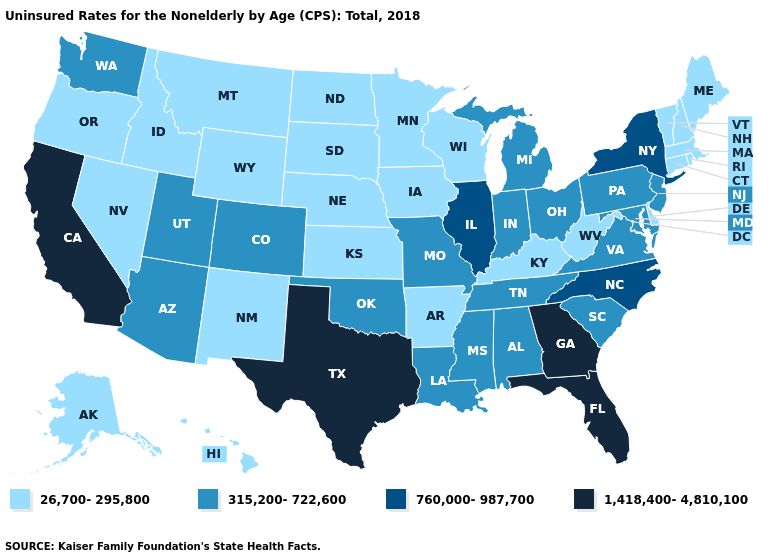What is the highest value in the MidWest ?
Write a very short answer. 760,000-987,700. How many symbols are there in the legend?
Write a very short answer. 4. What is the value of Massachusetts?
Quick response, please. 26,700-295,800. Does California have a higher value than Florida?
Concise answer only. No. What is the value of Ohio?
Quick response, please. 315,200-722,600. Among the states that border Texas , does Louisiana have the highest value?
Short answer required. Yes. What is the lowest value in the West?
Be succinct. 26,700-295,800. What is the highest value in the USA?
Answer briefly. 1,418,400-4,810,100. Which states have the lowest value in the USA?
Write a very short answer. Alaska, Arkansas, Connecticut, Delaware, Hawaii, Idaho, Iowa, Kansas, Kentucky, Maine, Massachusetts, Minnesota, Montana, Nebraska, Nevada, New Hampshire, New Mexico, North Dakota, Oregon, Rhode Island, South Dakota, Vermont, West Virginia, Wisconsin, Wyoming. What is the value of Montana?
Be succinct. 26,700-295,800. What is the value of Massachusetts?
Short answer required. 26,700-295,800. Which states have the lowest value in the USA?
Short answer required. Alaska, Arkansas, Connecticut, Delaware, Hawaii, Idaho, Iowa, Kansas, Kentucky, Maine, Massachusetts, Minnesota, Montana, Nebraska, Nevada, New Hampshire, New Mexico, North Dakota, Oregon, Rhode Island, South Dakota, Vermont, West Virginia, Wisconsin, Wyoming. Does the first symbol in the legend represent the smallest category?
Concise answer only. Yes. Name the states that have a value in the range 1,418,400-4,810,100?
Give a very brief answer. California, Florida, Georgia, Texas. What is the highest value in states that border Missouri?
Concise answer only. 760,000-987,700. 